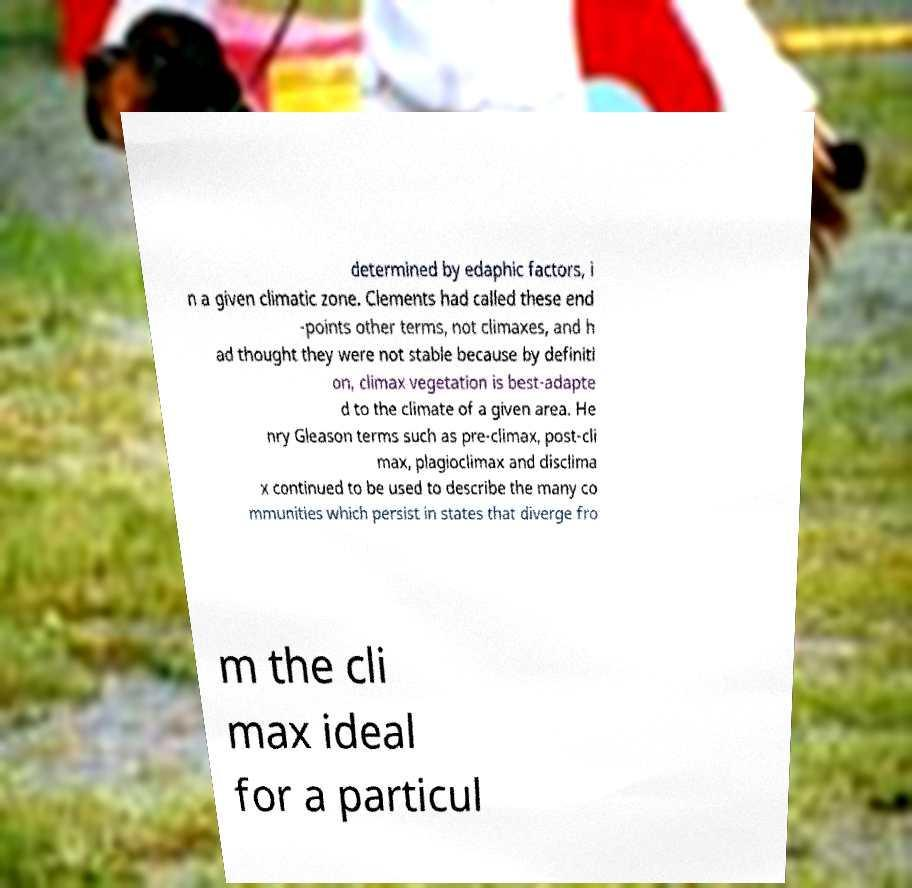Can you read and provide the text displayed in the image?This photo seems to have some interesting text. Can you extract and type it out for me? determined by edaphic factors, i n a given climatic zone. Clements had called these end -points other terms, not climaxes, and h ad thought they were not stable because by definiti on, climax vegetation is best-adapte d to the climate of a given area. He nry Gleason terms such as pre-climax, post-cli max, plagioclimax and disclima x continued to be used to describe the many co mmunities which persist in states that diverge fro m the cli max ideal for a particul 